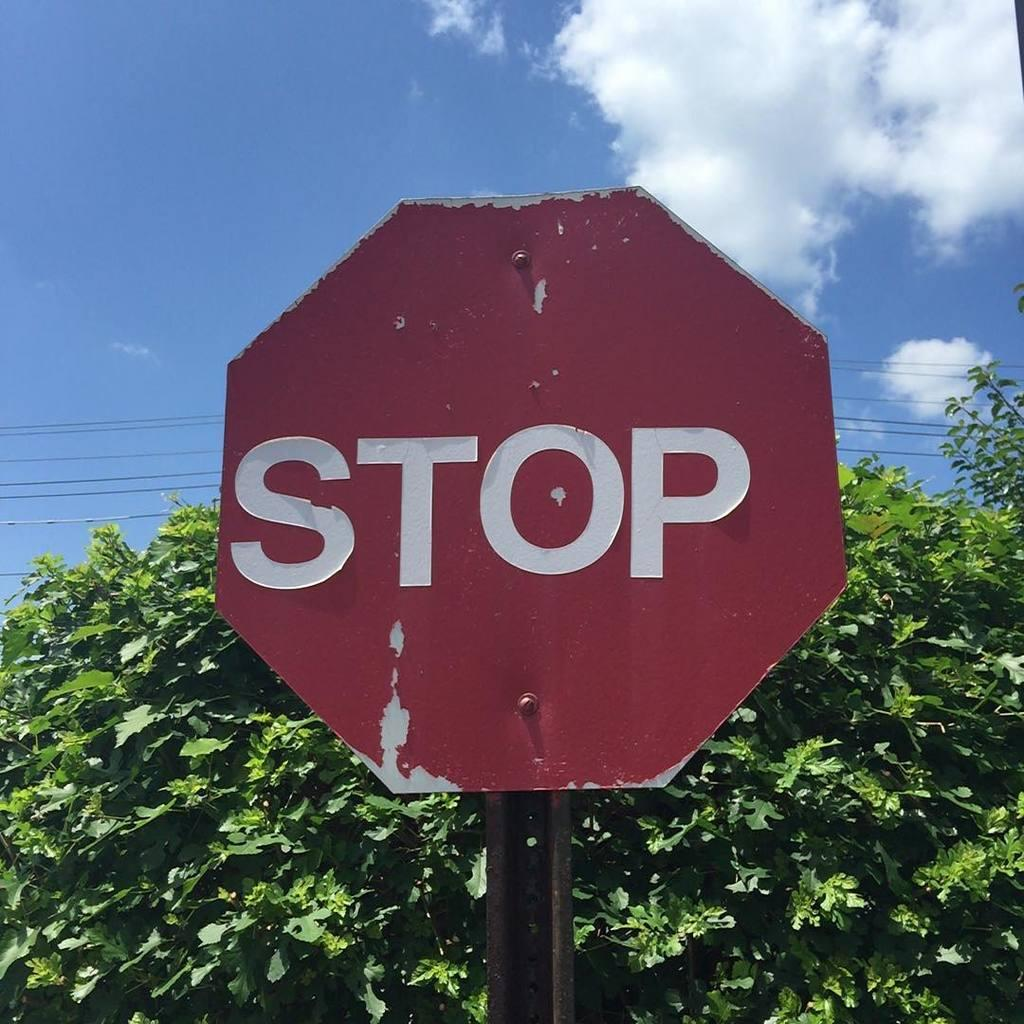<image>
Give a short and clear explanation of the subsequent image. An old faded Stop sign in front of a green bush on a sunny day. 